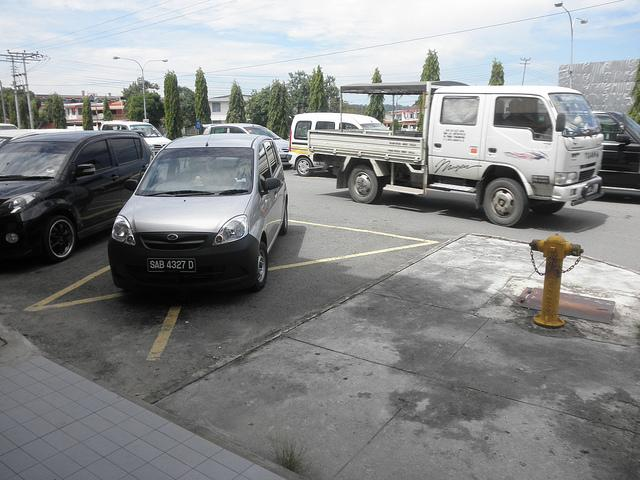Which car has violated the law? Please explain your reasoning. silver car. The silver car isn't parked correctly. 